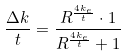Convert formula to latex. <formula><loc_0><loc_0><loc_500><loc_500>\frac { \Delta k } { t } = \frac { R ^ { \frac { 4 k _ { e } } { t } } \cdot 1 } { R ^ { \frac { 4 k _ { e } } { t } } + 1 }</formula> 